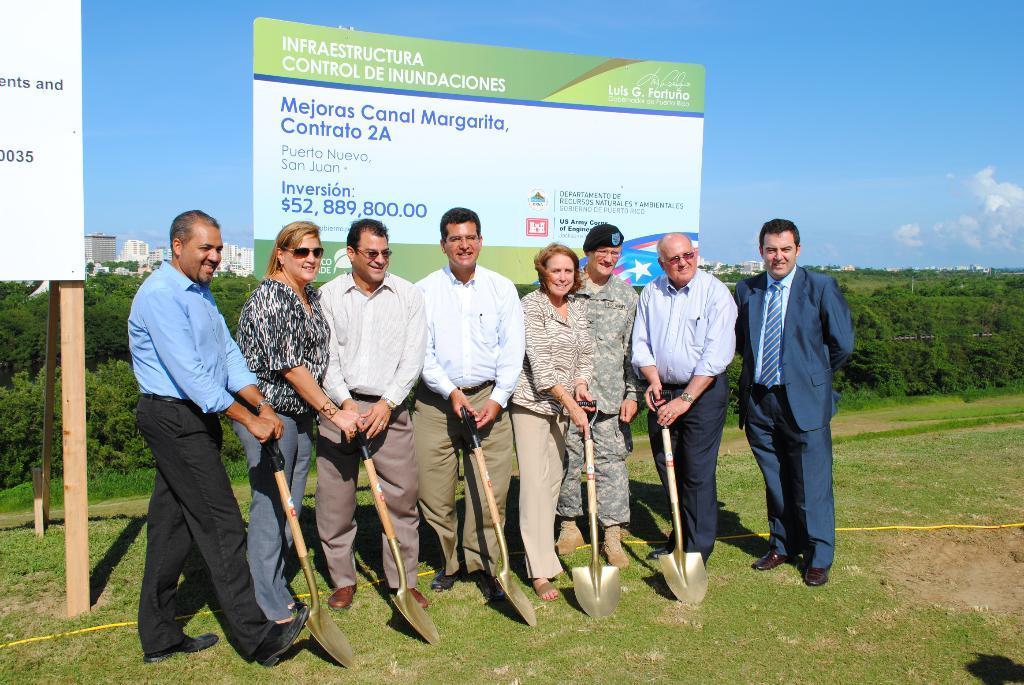Can you describe this image briefly? In this image there are group of people who are standing one beside the other by holding the shawl. Behind them there are hoardings. In the background there are plants. At the top there is the sky. At the bottom there is a ground on which there is yellow color wire. In the background there are buildings. 